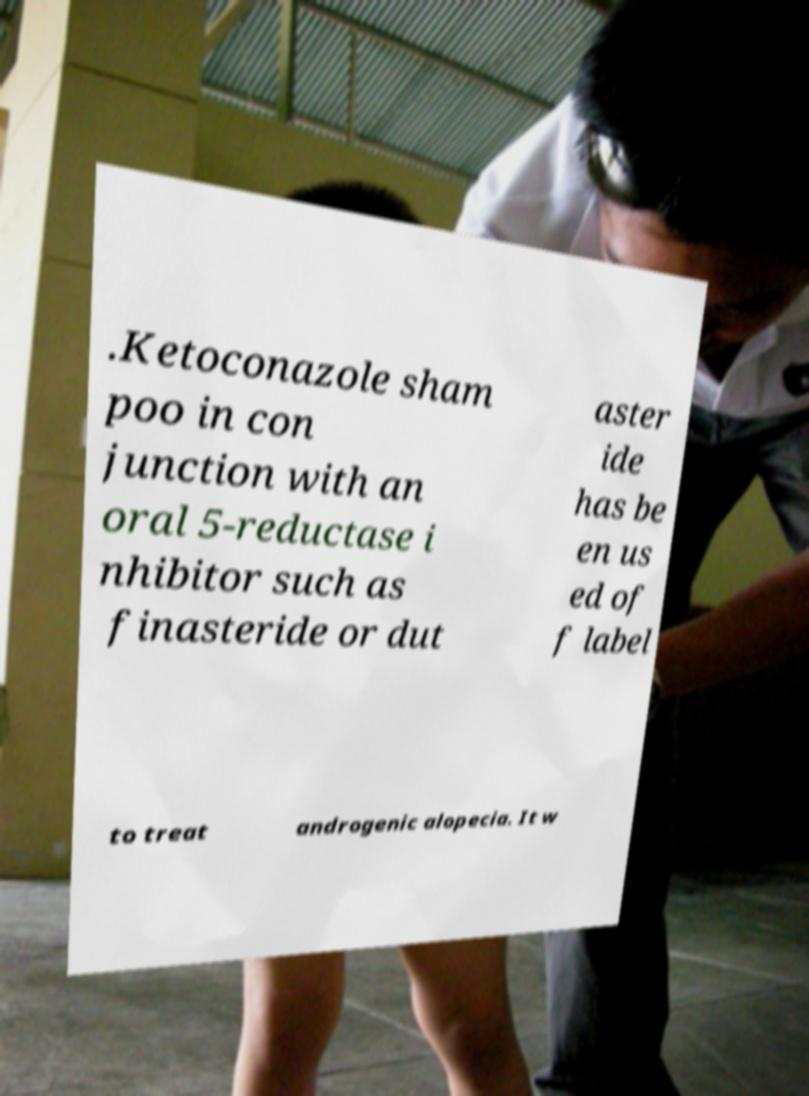Please read and relay the text visible in this image. What does it say? .Ketoconazole sham poo in con junction with an oral 5-reductase i nhibitor such as finasteride or dut aster ide has be en us ed of f label to treat androgenic alopecia. It w 